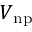<formula> <loc_0><loc_0><loc_500><loc_500>V _ { n p }</formula> 